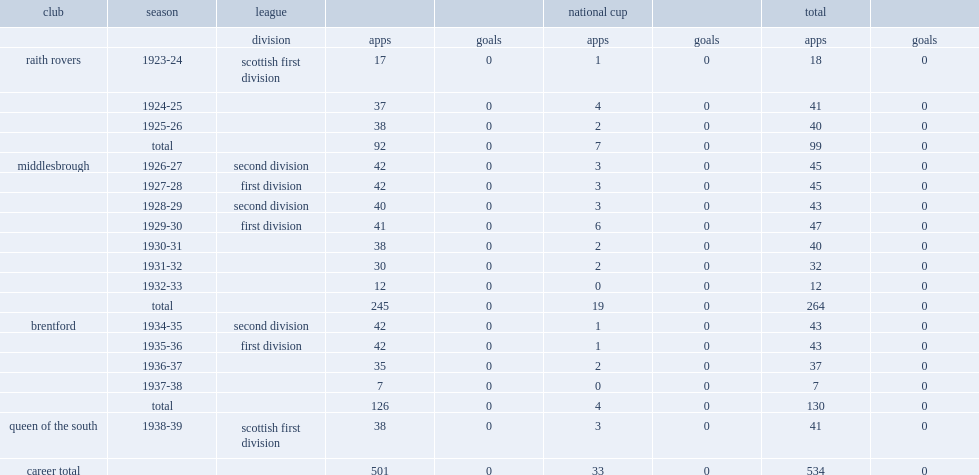Which club did james mathieson play for in 1928-29? Middlesbrough. 